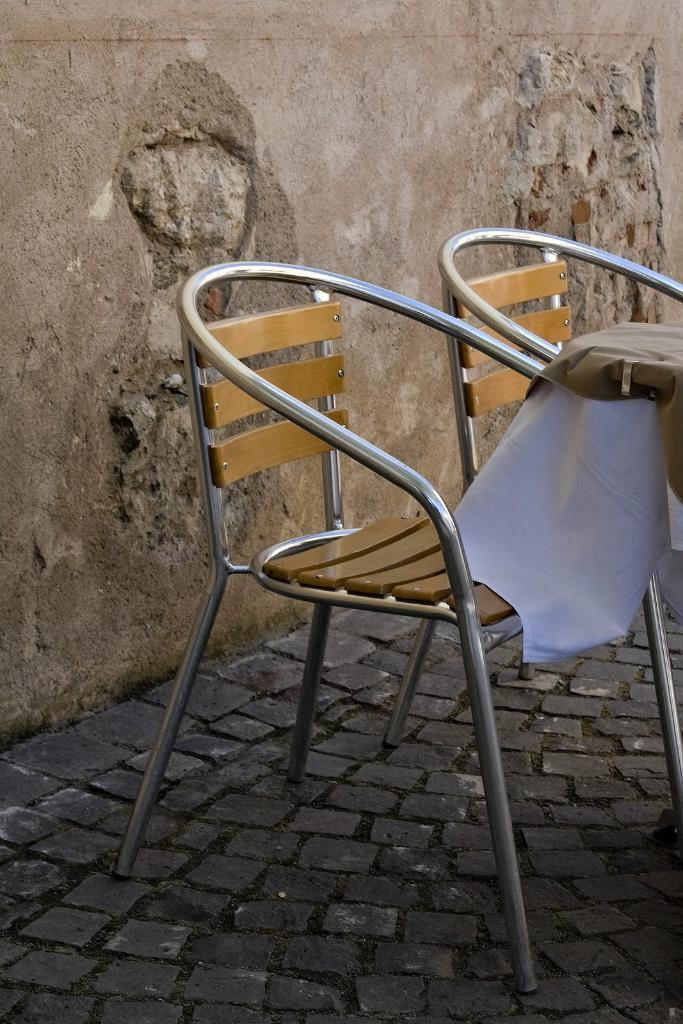In one or two sentences, can you explain what this image depicts? In this image we can see two chairs, there is a cloth on the table, also we can see the wall. 